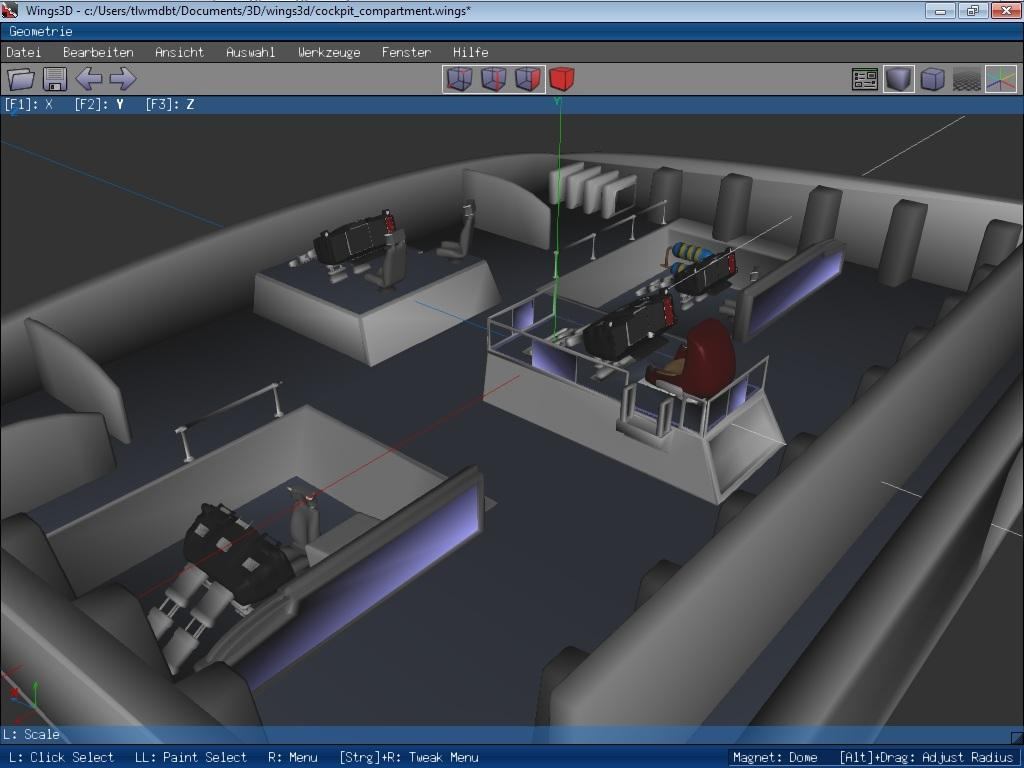What can be seen on the screen in the image? There is text visible on the screen, as well as objects and icons. Can you describe the text on the screen? Unfortunately, the specific text cannot be described without more information. What types of objects are displayed on the screen? The objects displayed on the screen cannot be described without more information. What do the icons on the screen represent? The icons on the screen cannot be described without more information. What type of doctor is comforting a patient in the field in the image? There is no doctor, patient, or field present in the image. 